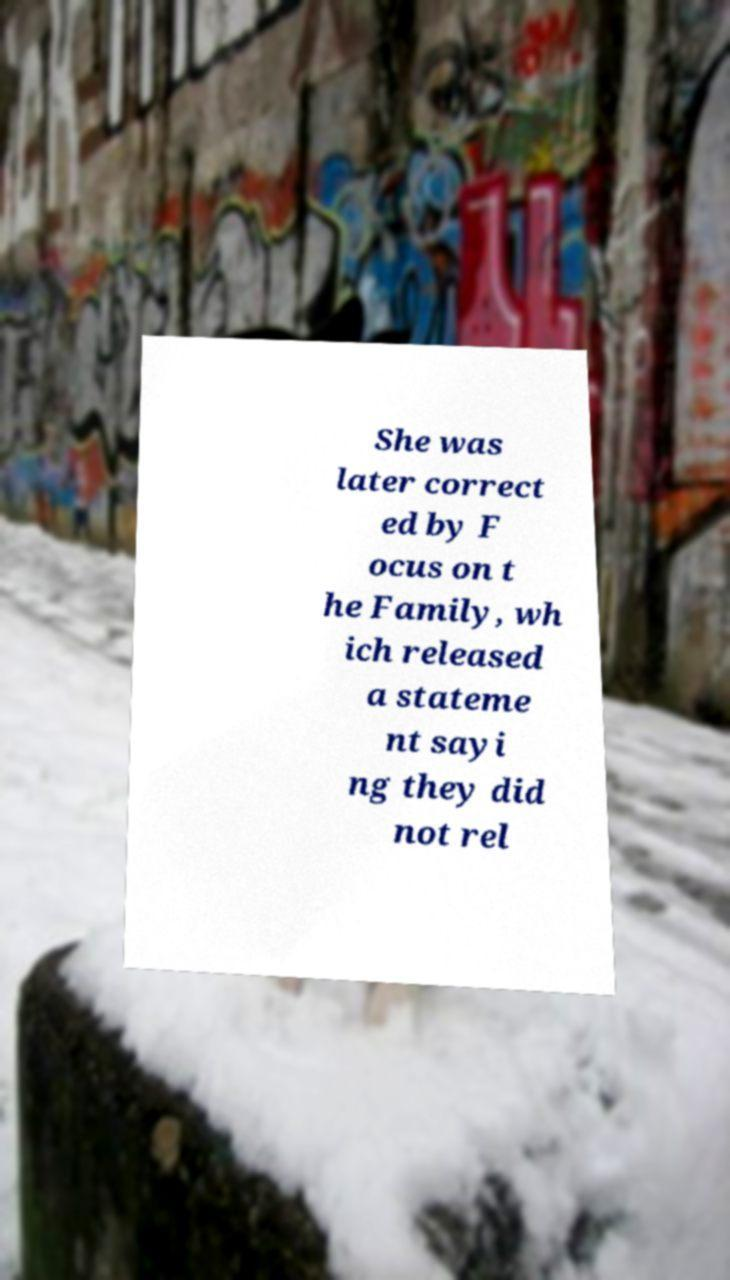Can you read and provide the text displayed in the image?This photo seems to have some interesting text. Can you extract and type it out for me? She was later correct ed by F ocus on t he Family, wh ich released a stateme nt sayi ng they did not rel 